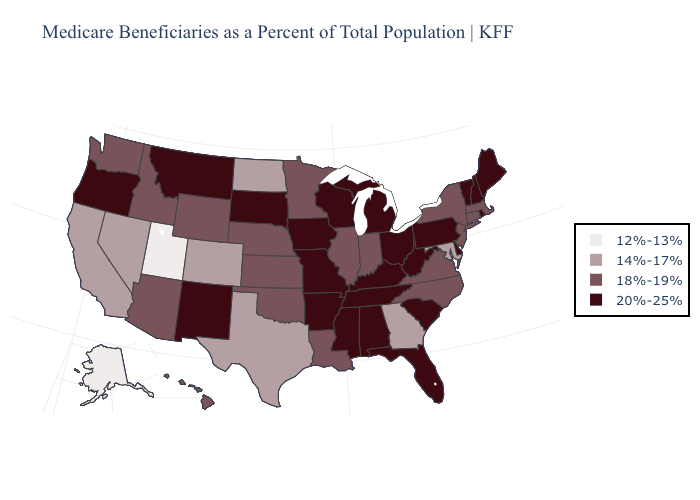Name the states that have a value in the range 12%-13%?
Quick response, please. Alaska, Utah. Name the states that have a value in the range 18%-19%?
Quick response, please. Arizona, Connecticut, Hawaii, Idaho, Illinois, Indiana, Kansas, Louisiana, Massachusetts, Minnesota, Nebraska, New Jersey, New York, North Carolina, Oklahoma, Virginia, Washington, Wyoming. Does South Carolina have the lowest value in the USA?
Keep it brief. No. What is the value of Wyoming?
Be succinct. 18%-19%. Is the legend a continuous bar?
Short answer required. No. Name the states that have a value in the range 14%-17%?
Keep it brief. California, Colorado, Georgia, Maryland, Nevada, North Dakota, Texas. Among the states that border Colorado , does New Mexico have the highest value?
Give a very brief answer. Yes. What is the highest value in states that border Wyoming?
Be succinct. 20%-25%. Name the states that have a value in the range 18%-19%?
Keep it brief. Arizona, Connecticut, Hawaii, Idaho, Illinois, Indiana, Kansas, Louisiana, Massachusetts, Minnesota, Nebraska, New Jersey, New York, North Carolina, Oklahoma, Virginia, Washington, Wyoming. Name the states that have a value in the range 12%-13%?
Keep it brief. Alaska, Utah. Which states have the lowest value in the Northeast?
Write a very short answer. Connecticut, Massachusetts, New Jersey, New York. What is the value of Hawaii?
Short answer required. 18%-19%. What is the value of Nevada?
Answer briefly. 14%-17%. Does Nevada have the highest value in the USA?
Write a very short answer. No. Which states have the lowest value in the MidWest?
Keep it brief. North Dakota. 